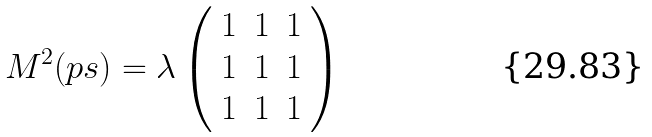<formula> <loc_0><loc_0><loc_500><loc_500>M ^ { 2 } ( p s ) = \lambda \left ( \begin{array} { c c c } 1 & 1 & 1 \\ 1 & 1 & 1 \\ 1 & 1 & 1 \end{array} \right )</formula> 